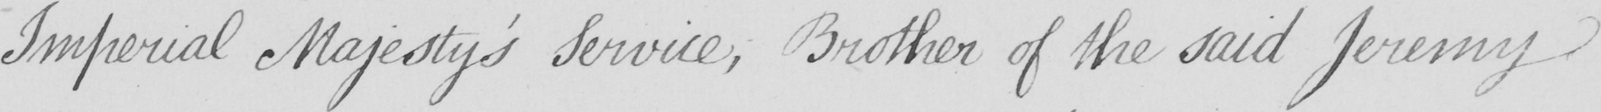What does this handwritten line say? Imperial Majesty ' s Service , Brother of the said Jeremy 